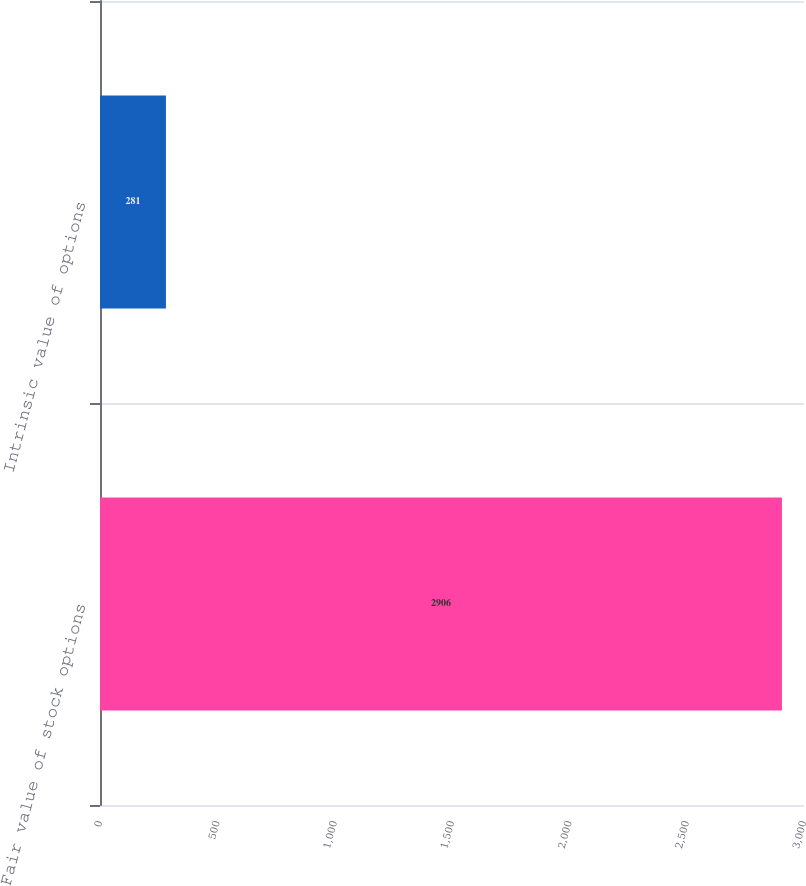Convert chart to OTSL. <chart><loc_0><loc_0><loc_500><loc_500><bar_chart><fcel>Fair value of stock options<fcel>Intrinsic value of options<nl><fcel>2906<fcel>281<nl></chart> 